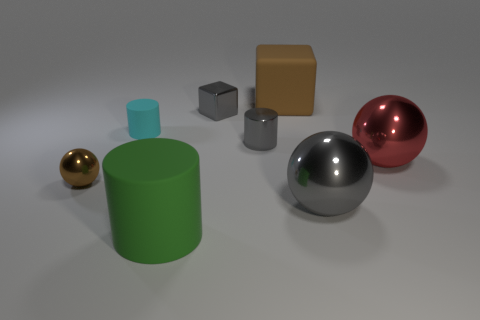Add 1 brown matte cubes. How many objects exist? 9 Subtract all cylinders. How many objects are left? 5 Subtract 0 cyan cubes. How many objects are left? 8 Subtract all small red metal things. Subtract all small gray things. How many objects are left? 6 Add 7 gray metallic blocks. How many gray metallic blocks are left? 8 Add 8 green rubber spheres. How many green rubber spheres exist? 8 